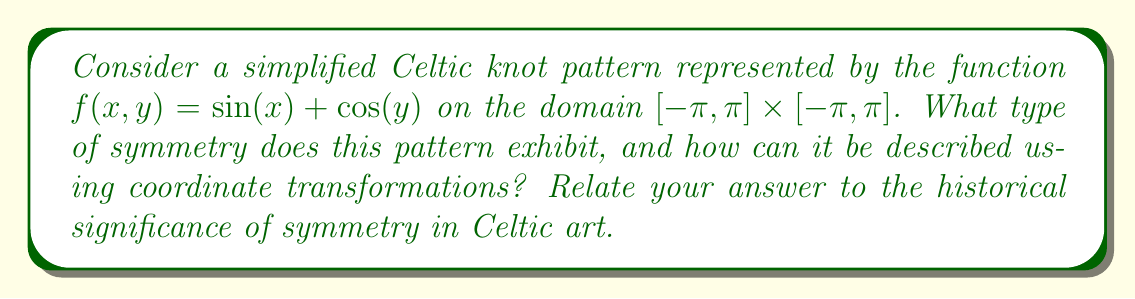What is the answer to this math problem? To analyze the symmetry of this Celtic knot pattern, we'll follow these steps:

1) First, let's consider the properties of the function $f(x,y) = \sin(x) + \cos(y)$:

   a) $\sin(-x) = -\sin(x)$
   b) $\cos(-y) = \cos(y)$

2) Now, let's apply various transformations:

   a) Reflection about y-axis: $f(-x,y) = -\sin(x) + \cos(y) = -f(x,y)$
   b) Reflection about x-axis: $f(x,-y) = \sin(x) + \cos(-y) = \sin(x) + \cos(y) = f(x,y)$
   c) Rotation by 180°: $f(-x,-y) = -\sin(x) + \cos(y) = -f(x,y)$

3) From these transformations, we can conclude:
   - The pattern has reflectional symmetry about the x-axis
   - The pattern has rotational symmetry of order 2 (180° rotation)

4) In terms of coordinate transformations:
   - Reflection about x-axis: $(x,y) \rightarrow (x,-y)$
   - 180° rotation: $(x,y) \rightarrow (-x,-y)$

5) Historical significance:
   Symmetry was a crucial element in Celtic art, representing balance and harmony in nature and spirituality. The use of reflection and rotation in knot patterns was not just aesthetic but often carried symbolic meaning, such as the cyclical nature of life or the interconnectedness of all things.

6) The simplified function we analyzed captures some key aspects of Celtic knot symmetry, particularly the balance and repetition seen in traditional designs. However, real Celtic knots often have more complex symmetries, including translational symmetry and higher-order rotational symmetry.
Answer: Reflectional symmetry about x-axis and rotational symmetry of order 2, representing balance and interconnectedness in Celtic art. 